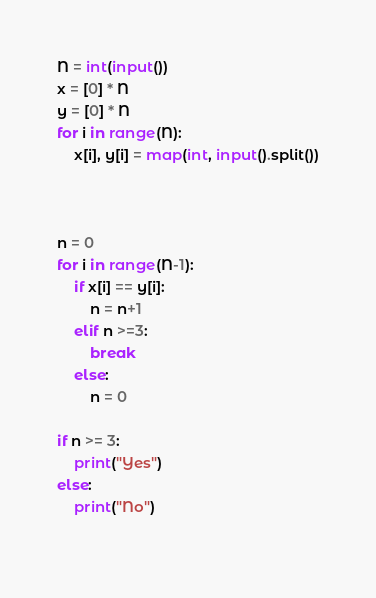<code> <loc_0><loc_0><loc_500><loc_500><_Python_>N = int(input())
x = [0] * N
y = [0] * N
for i in range(N):
    x[i], y[i] = map(int, input().split())
          


n = 0
for i in range(N-1):
    if x[i] == y[i]:
        n = n+1
    elif n >=3:
        break
    else:
        n = 0

if n >= 3:
    print("Yes")
else:
    print("No")
        </code> 